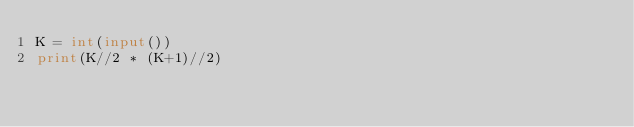Convert code to text. <code><loc_0><loc_0><loc_500><loc_500><_Python_>K = int(input())
print(K//2 * (K+1)//2)</code> 